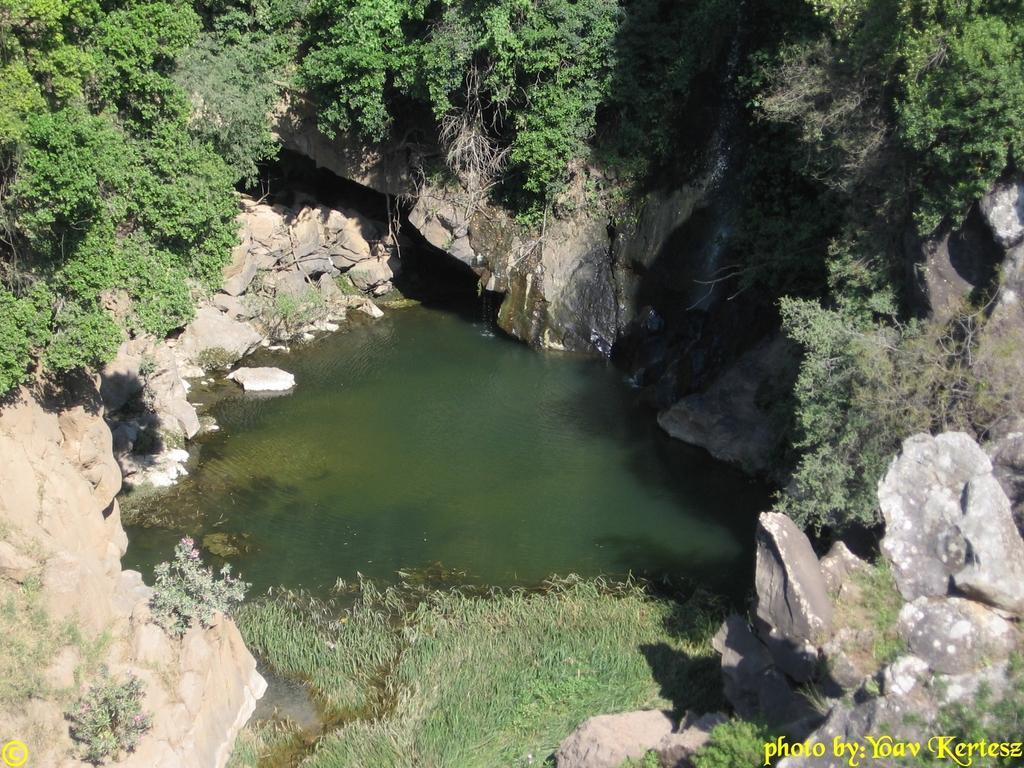Could you give a brief overview of what you see in this image? In this image there is a pond, around the pond there are hills, on that hills there are trees, in the bottom right and in the bottom left there is text. 